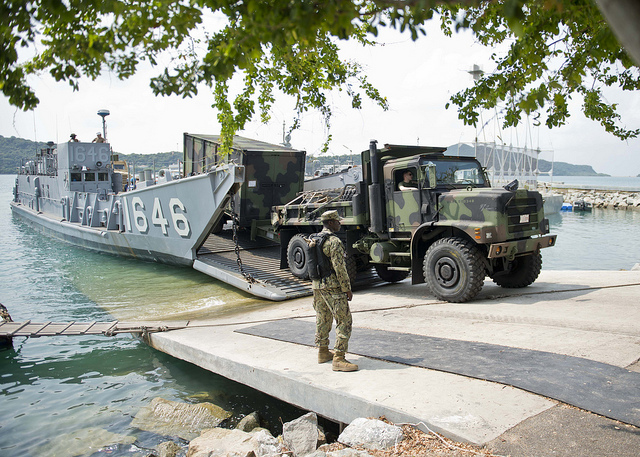Describe the environment around the military operation. The environment surrounding the military operation appears to be a coastal area with a dock. The water is calm, suggesting a likely sheltered bay. There are several large vessels in the background, possibly other military or support ships. The presence of foliage, as seen from the tree branches in the foreground, indicates that the dock area is situated near a green and possibly wooded region. The overall setting portrays a well-coordinated and secure operation location, ideal for loading and unloading large vehicles and equipment. 